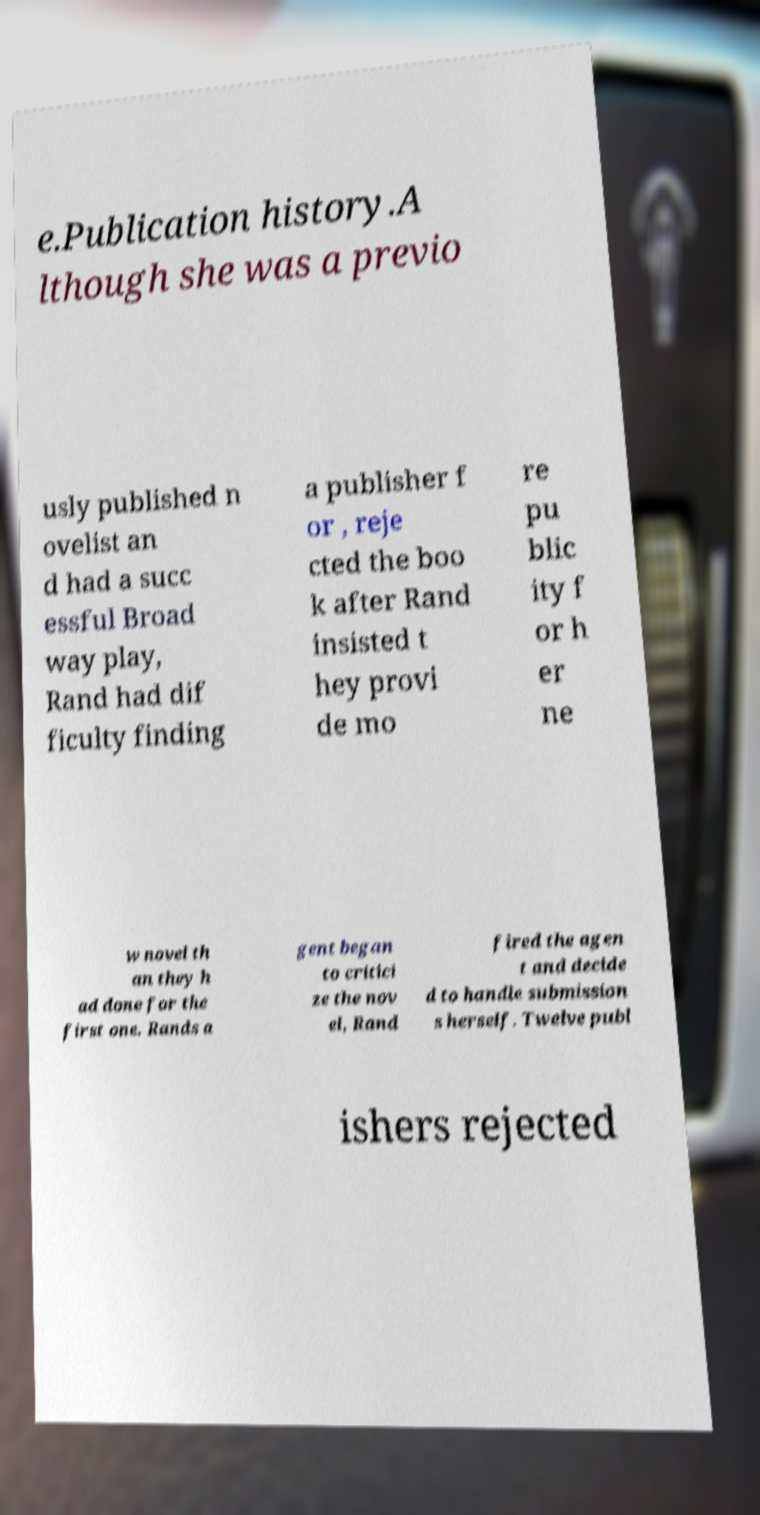Can you read and provide the text displayed in the image?This photo seems to have some interesting text. Can you extract and type it out for me? e.Publication history.A lthough she was a previo usly published n ovelist an d had a succ essful Broad way play, Rand had dif ficulty finding a publisher f or , reje cted the boo k after Rand insisted t hey provi de mo re pu blic ity f or h er ne w novel th an they h ad done for the first one. Rands a gent began to critici ze the nov el, Rand fired the agen t and decide d to handle submission s herself. Twelve publ ishers rejected 